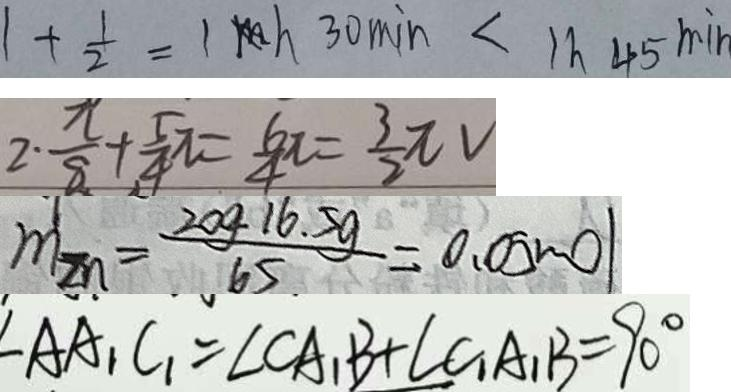Convert formula to latex. <formula><loc_0><loc_0><loc_500><loc_500>1 + \frac { 1 } { 2 } = 1 h 3 0 \min < 1 h 4 5 \min 
 2 \cdot \frac { \pi } { 8 } + \frac { 5 } { 4 } \pi = \frac { 6 } { 4 } \pi = \frac { 3 } { 2 } \pi V 
 m _ { 2 n } = \frac { 2 0 g 1 6 . 5 g } { 6 5 } = 0 . 0 5 m o l 
 \angle A A _ { 1 } C _ { 1 } = \angle C A _ { 1 } B + \angle C _ { 1 } A _ { 1 } B = 9 0 ^ { \circ }</formula> 